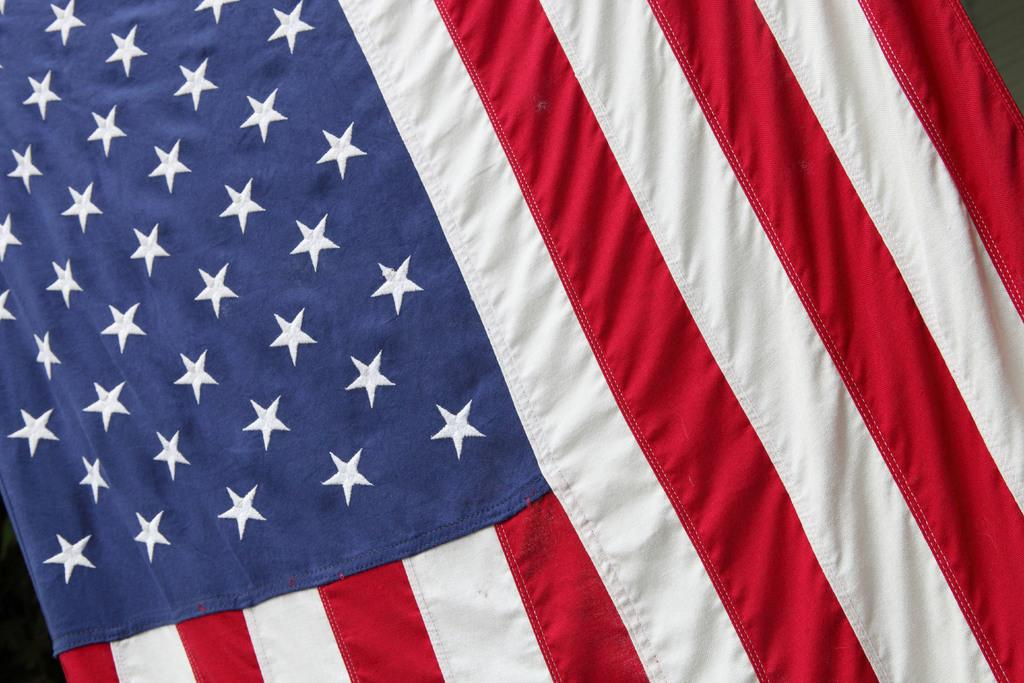What flag is visible in the image? The American flag is present in the image. How many grapes are on the page in the image? There are no grapes or pages present in the image; it only features the American flag. 